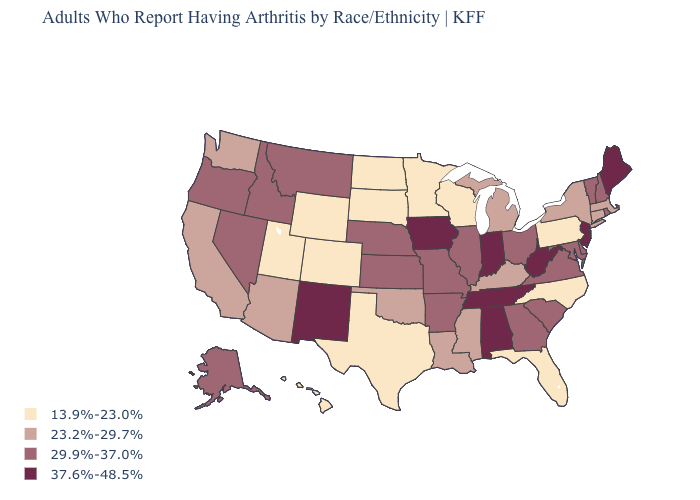Is the legend a continuous bar?
Keep it brief. No. Which states have the lowest value in the USA?
Quick response, please. Colorado, Florida, Hawaii, Minnesota, North Carolina, North Dakota, Pennsylvania, South Dakota, Texas, Utah, Wisconsin, Wyoming. What is the value of Michigan?
Be succinct. 23.2%-29.7%. Does the map have missing data?
Short answer required. No. What is the value of Iowa?
Concise answer only. 37.6%-48.5%. Which states have the lowest value in the West?
Concise answer only. Colorado, Hawaii, Utah, Wyoming. What is the value of Louisiana?
Concise answer only. 23.2%-29.7%. How many symbols are there in the legend?
Keep it brief. 4. What is the value of Ohio?
Give a very brief answer. 29.9%-37.0%. What is the value of Washington?
Concise answer only. 23.2%-29.7%. What is the value of New Jersey?
Answer briefly. 37.6%-48.5%. What is the value of Wisconsin?
Quick response, please. 13.9%-23.0%. Name the states that have a value in the range 37.6%-48.5%?
Give a very brief answer. Alabama, Indiana, Iowa, Maine, New Jersey, New Mexico, Tennessee, West Virginia. Name the states that have a value in the range 23.2%-29.7%?
Give a very brief answer. Arizona, California, Connecticut, Kentucky, Louisiana, Massachusetts, Michigan, Mississippi, New York, Oklahoma, Washington. Does California have the same value as New Hampshire?
Be succinct. No. 